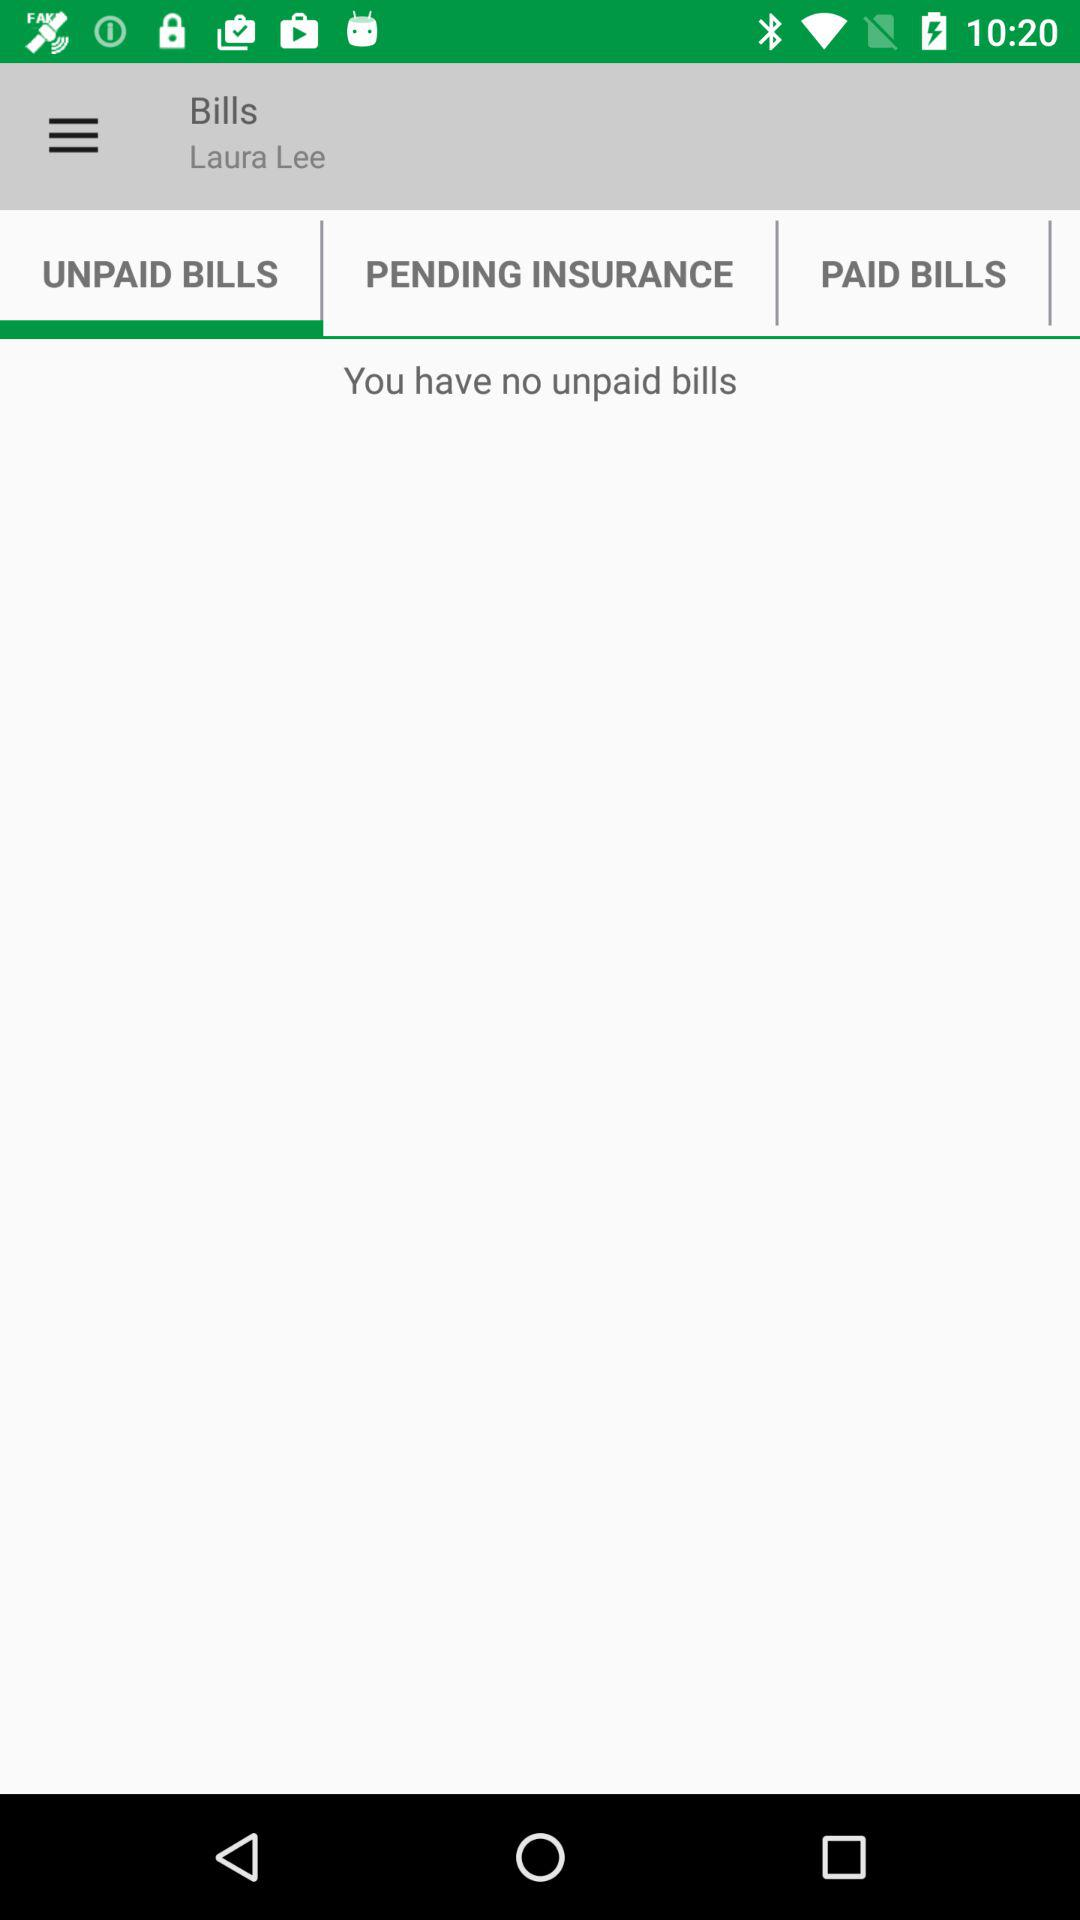How many unpaid bills does Laura Lee have?
Answer the question using a single word or phrase. 0 